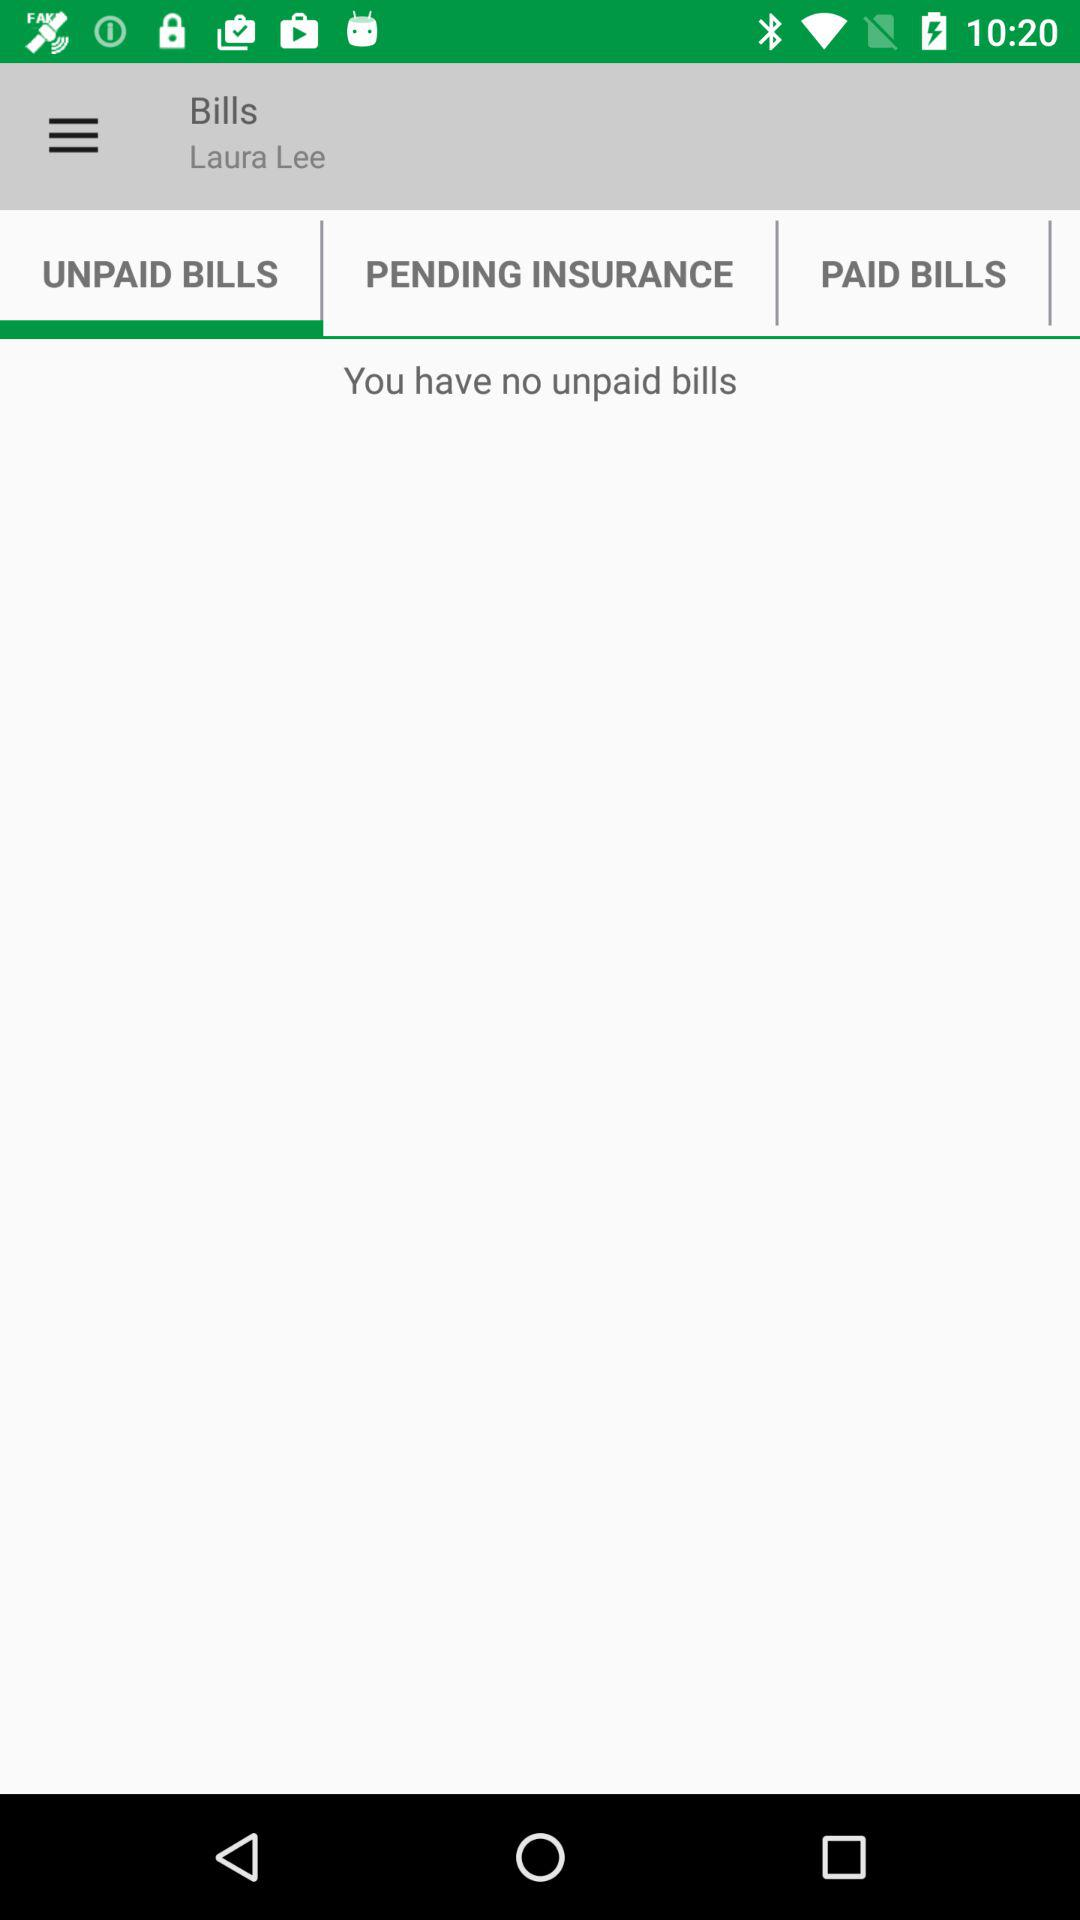How many unpaid bills does Laura Lee have?
Answer the question using a single word or phrase. 0 